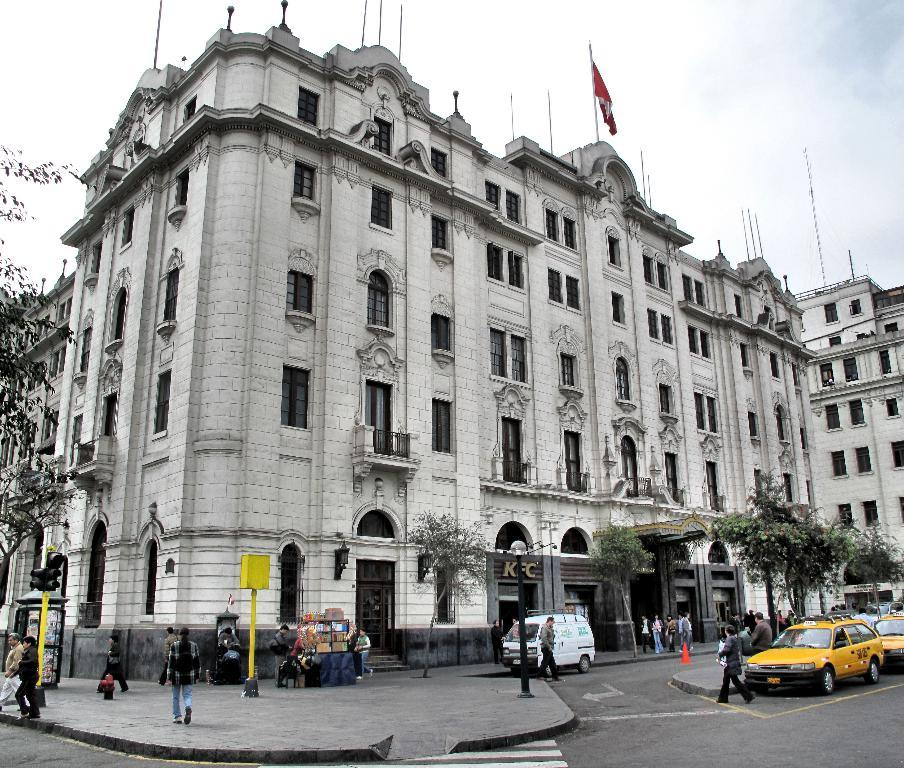What type of vehicles can be seen in the image? There are cars in the image. What objects are present in the image that are typically used for traffic control? There are poles, a traffic signal, a traffic cone, and a flag in the image. What type of natural elements can be seen in the image? There are trees in the image. What type of structure is visible in the background of the image? There are buildings in the background of the image. What is visible in the sky in the image? There is sky visible in the background of the image. Are there any people present in the image? Yes, there are persons in the image. What additional object can be seen in the image? There is a board in the image. What type of button can be seen on the cars in the image? There are no buttons visible on the cars in the image. How does the size of the trees in the image compare to the size of the cars? The size of the trees in the image cannot be compared to the size of the cars, as the image does not provide a scale for comparison. 